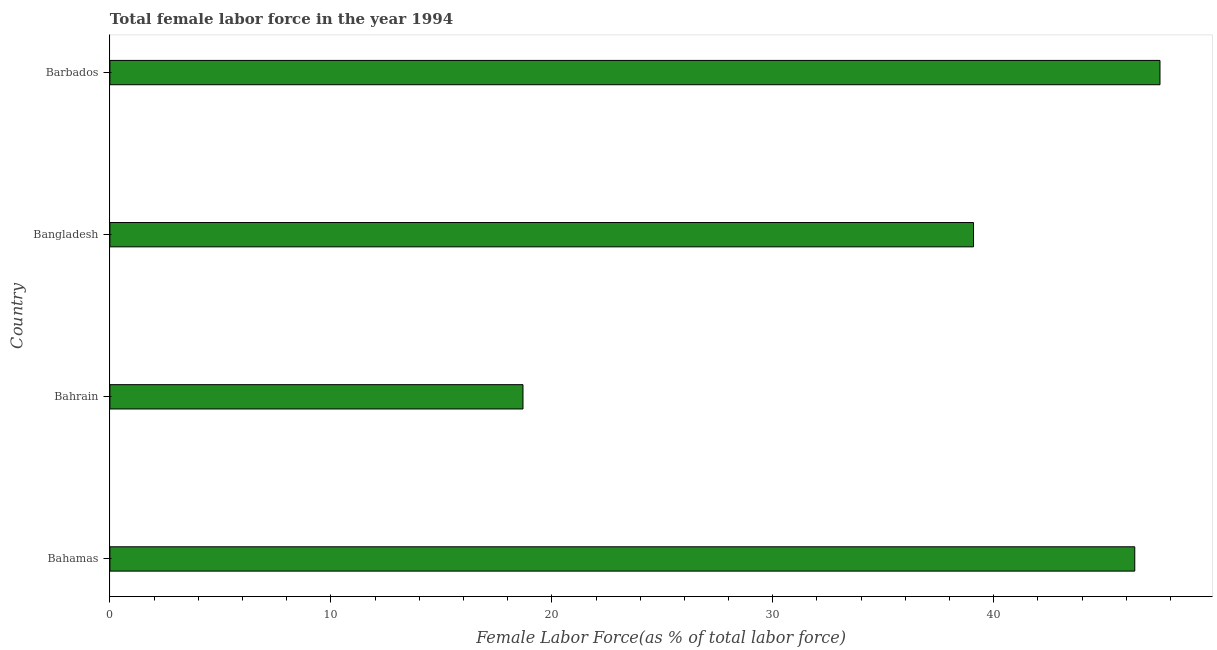What is the title of the graph?
Provide a short and direct response. Total female labor force in the year 1994. What is the label or title of the X-axis?
Your response must be concise. Female Labor Force(as % of total labor force). What is the total female labor force in Bangladesh?
Provide a succinct answer. 39.09. Across all countries, what is the maximum total female labor force?
Keep it short and to the point. 47.52. Across all countries, what is the minimum total female labor force?
Provide a short and direct response. 18.7. In which country was the total female labor force maximum?
Give a very brief answer. Barbados. In which country was the total female labor force minimum?
Provide a succinct answer. Bahrain. What is the sum of the total female labor force?
Your answer should be compact. 151.69. What is the difference between the total female labor force in Bahamas and Bahrain?
Keep it short and to the point. 27.69. What is the average total female labor force per country?
Keep it short and to the point. 37.92. What is the median total female labor force?
Your response must be concise. 42.73. In how many countries, is the total female labor force greater than 4 %?
Provide a succinct answer. 4. What is the ratio of the total female labor force in Bahrain to that in Bangladesh?
Ensure brevity in your answer.  0.48. What is the difference between the highest and the second highest total female labor force?
Give a very brief answer. 1.14. Is the sum of the total female labor force in Bangladesh and Barbados greater than the maximum total female labor force across all countries?
Provide a succinct answer. Yes. What is the difference between the highest and the lowest total female labor force?
Provide a short and direct response. 28.83. In how many countries, is the total female labor force greater than the average total female labor force taken over all countries?
Your answer should be compact. 3. Are the values on the major ticks of X-axis written in scientific E-notation?
Provide a short and direct response. No. What is the Female Labor Force(as % of total labor force) of Bahamas?
Keep it short and to the point. 46.38. What is the Female Labor Force(as % of total labor force) in Bahrain?
Keep it short and to the point. 18.7. What is the Female Labor Force(as % of total labor force) in Bangladesh?
Make the answer very short. 39.09. What is the Female Labor Force(as % of total labor force) in Barbados?
Your response must be concise. 47.52. What is the difference between the Female Labor Force(as % of total labor force) in Bahamas and Bahrain?
Offer a terse response. 27.69. What is the difference between the Female Labor Force(as % of total labor force) in Bahamas and Bangladesh?
Provide a succinct answer. 7.3. What is the difference between the Female Labor Force(as % of total labor force) in Bahamas and Barbados?
Offer a very short reply. -1.14. What is the difference between the Female Labor Force(as % of total labor force) in Bahrain and Bangladesh?
Give a very brief answer. -20.39. What is the difference between the Female Labor Force(as % of total labor force) in Bahrain and Barbados?
Your answer should be very brief. -28.83. What is the difference between the Female Labor Force(as % of total labor force) in Bangladesh and Barbados?
Provide a short and direct response. -8.44. What is the ratio of the Female Labor Force(as % of total labor force) in Bahamas to that in Bahrain?
Provide a succinct answer. 2.48. What is the ratio of the Female Labor Force(as % of total labor force) in Bahamas to that in Bangladesh?
Give a very brief answer. 1.19. What is the ratio of the Female Labor Force(as % of total labor force) in Bahrain to that in Bangladesh?
Provide a short and direct response. 0.48. What is the ratio of the Female Labor Force(as % of total labor force) in Bahrain to that in Barbados?
Offer a very short reply. 0.39. What is the ratio of the Female Labor Force(as % of total labor force) in Bangladesh to that in Barbados?
Provide a short and direct response. 0.82. 